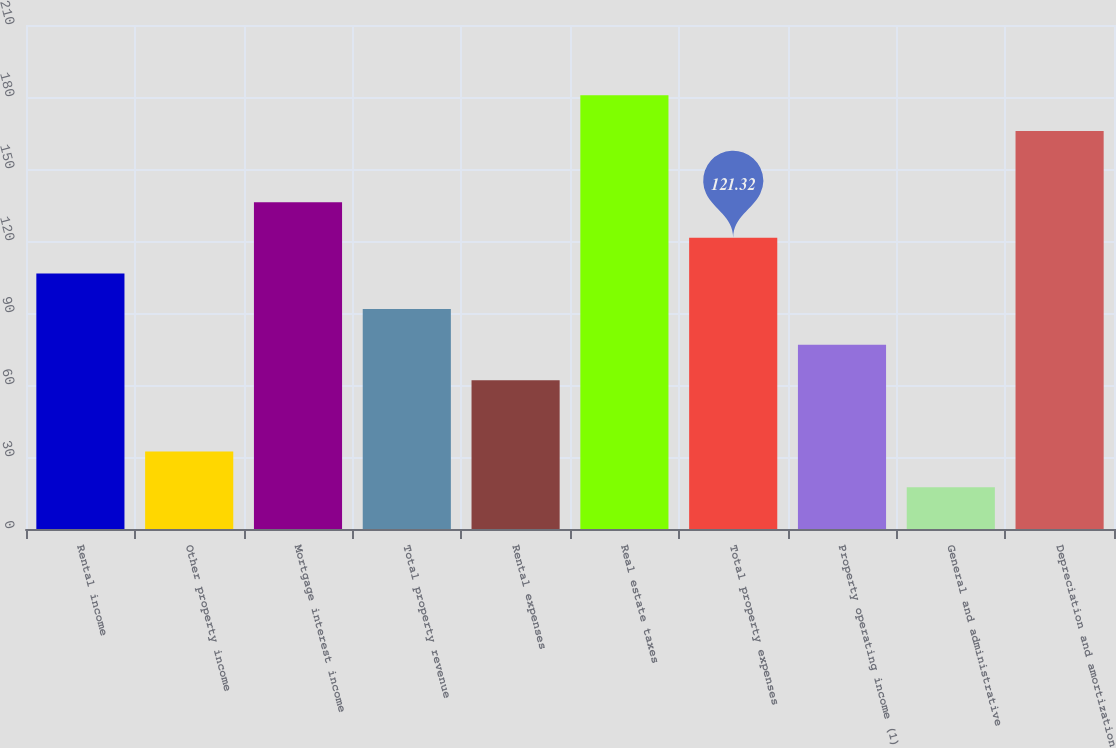Convert chart. <chart><loc_0><loc_0><loc_500><loc_500><bar_chart><fcel>Rental income<fcel>Other property income<fcel>Mortgage interest income<fcel>Total property revenue<fcel>Rental expenses<fcel>Real estate taxes<fcel>Total property expenses<fcel>Property operating income (1)<fcel>General and administrative<fcel>Depreciation and amortization<nl><fcel>106.48<fcel>32.28<fcel>136.16<fcel>91.64<fcel>61.96<fcel>180.68<fcel>121.32<fcel>76.8<fcel>17.44<fcel>165.84<nl></chart> 